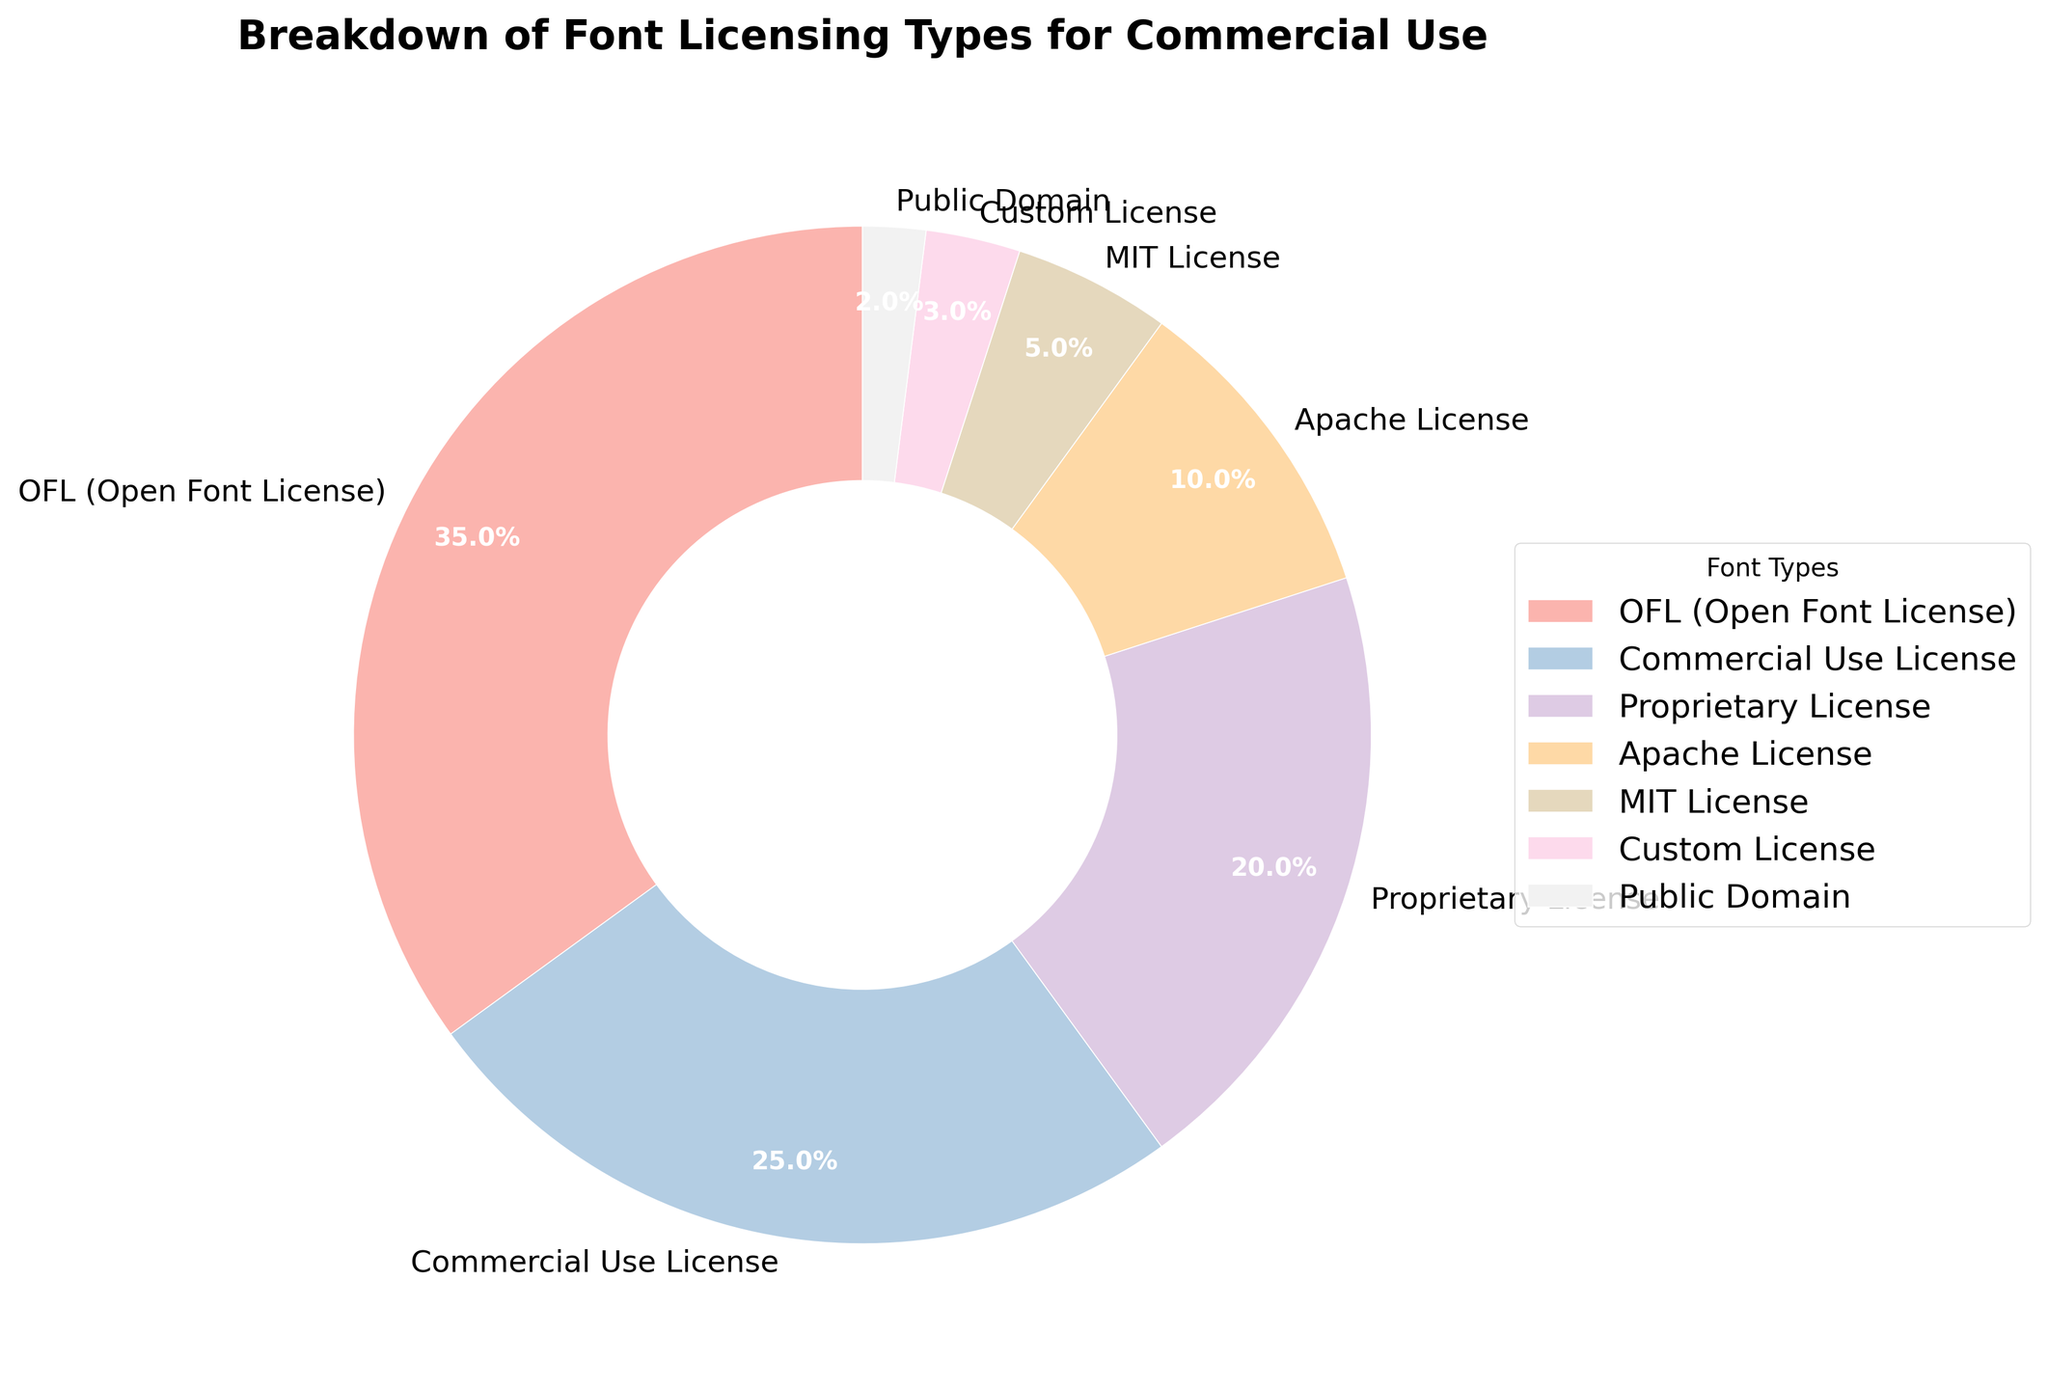What percentage of fonts have an Open Font License (OFL)? By looking at the labeled sections of the pie chart, the slice labeled "OFL (Open Font License)" represents 35% of the total.
Answer: 35% Which font licensing type has the smallest percentage, and what is it? The smallest percentage can be identified by checking the smallest slice in the pie chart, which is labeled "Public Domain" and represents 2%.
Answer: Public Domain, 2% What is the combined percentage of proprietary and Apache licensed fonts? Add the percentages of the slices labeled "Proprietary License" and "Apache License" (20% and 10% respectively). 20% + 10% equals 30%.
Answer: 30% Which licensing type has a greater percentage: MIT License or Custom License? Compare the percentages of the slices labeled "MIT License" and "Custom License". MIT License is 5%, Custom License is 3%, hence MIT License has a greater percentage.
Answer: MIT License What is the most common font licensing type for commercial use? Identify the largest slice of the pie chart, which is labeled "OFL (Open Font License)" at 35%.
Answer: OFL (Open Font License) What is the percentage difference between the fonts with Commercial Use License and Proprietary License? Subtract the percentage of Proprietary License (20%) from the percentage of Commercial Use License (25%). 25% - 20% equals 5%.
Answer: 5% How many licensing types have a percentage greater than 20%? Count the slices with percentages greater than 20%. The OFL (35%) and Commercial Use License (25%) slices meet this criterion, so there are 2.
Answer: 2 What is the combined percentage of the three least common licensing types? Add the percentages of the slices labeled "Public Domain" (2%), "Custom License" (3%), and "MIT License" (5%). 2% + 3% + 5% equals 10%.
Answer: 10% Which licensing type represented in green on the pie chart? Identify the slice that is colored green. This color scheme is subjective, but from the Pastel1 palette, the fourth slice is likely green, which corresponds to "Apache License".
Answer: Apache License 